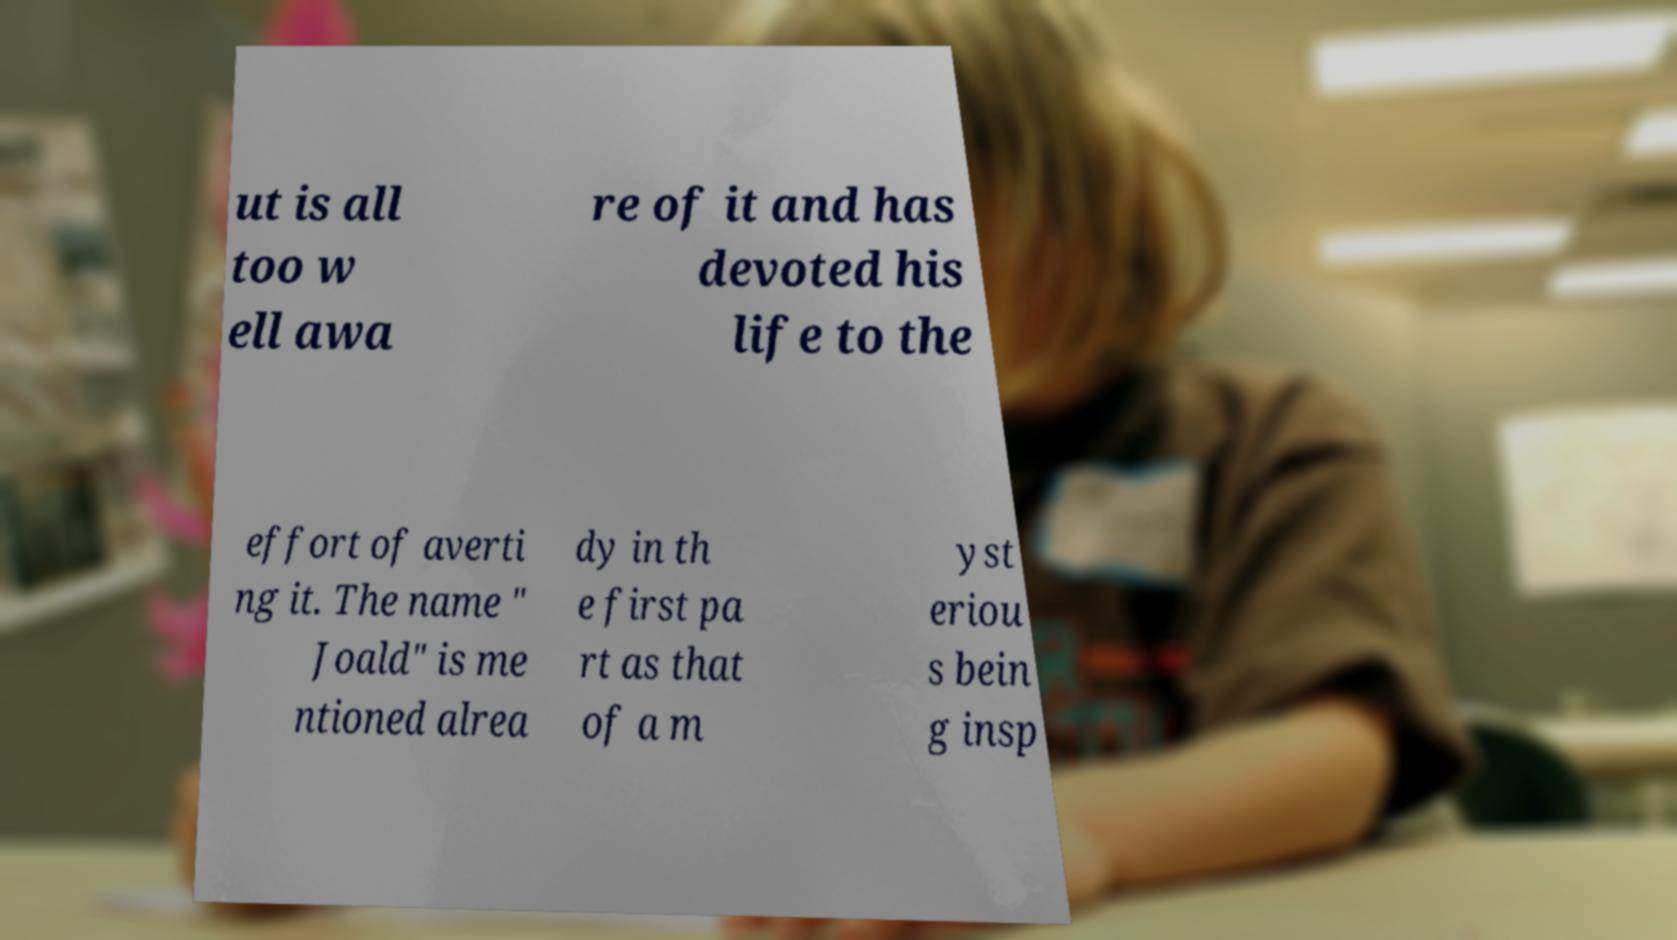Can you accurately transcribe the text from the provided image for me? ut is all too w ell awa re of it and has devoted his life to the effort of averti ng it. The name " Joald" is me ntioned alrea dy in th e first pa rt as that of a m yst eriou s bein g insp 